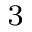Convert formula to latex. <formula><loc_0><loc_0><loc_500><loc_500>^ { 3 }</formula> 